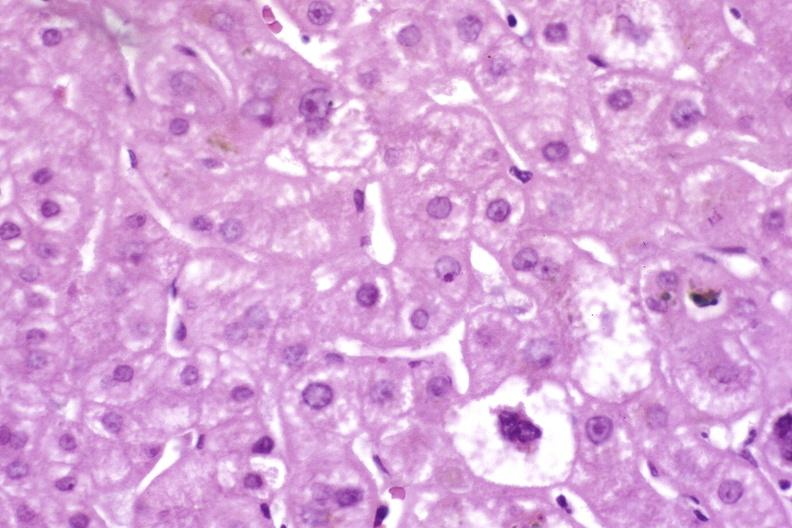what is present?
Answer the question using a single word or phrase. Hepatobiliary 